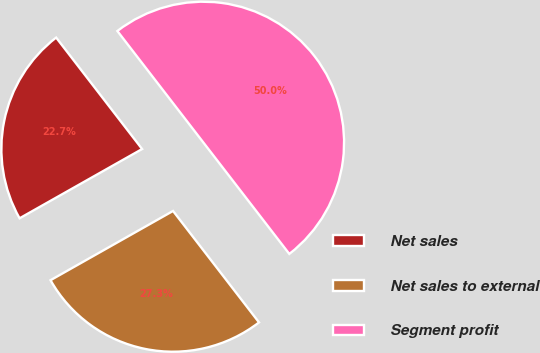Convert chart. <chart><loc_0><loc_0><loc_500><loc_500><pie_chart><fcel>Net sales<fcel>Net sales to external<fcel>Segment profit<nl><fcel>22.73%<fcel>27.27%<fcel>50.0%<nl></chart> 